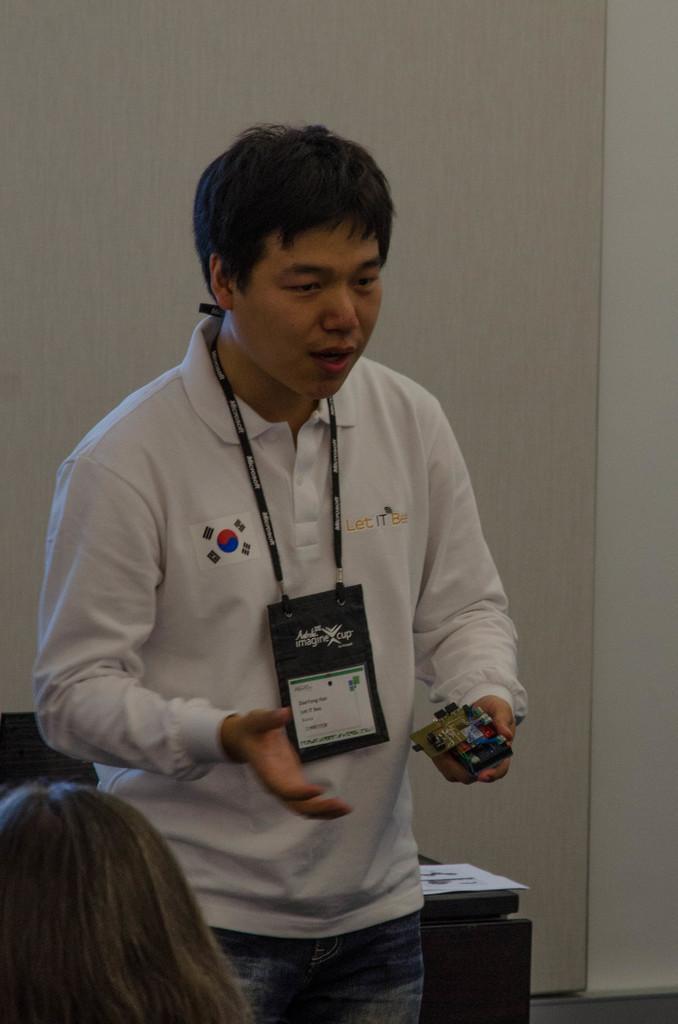In one or two sentences, can you explain what this image depicts? In this picture we can see a person standing and holding something in his hand, he wore a white color t-shirt, in the background there is a wall, at the left bottom we can see one more person's head. 